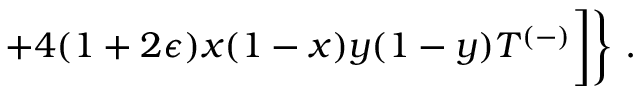Convert formula to latex. <formula><loc_0><loc_0><loc_500><loc_500>+ 4 ( 1 + 2 \epsilon ) x ( 1 - x ) y ( 1 - y ) T ^ { ( - ) } \Big ] \Big \} .</formula> 